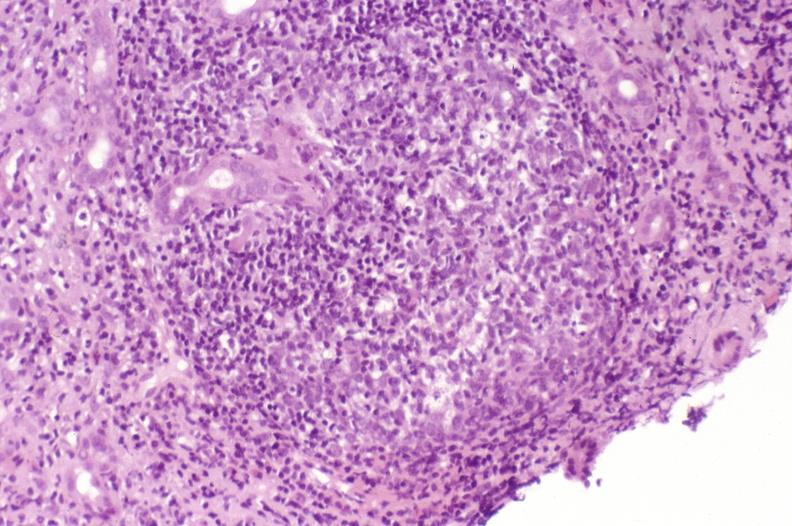does this image show recurrent hepatitis c virus?
Answer the question using a single word or phrase. Yes 